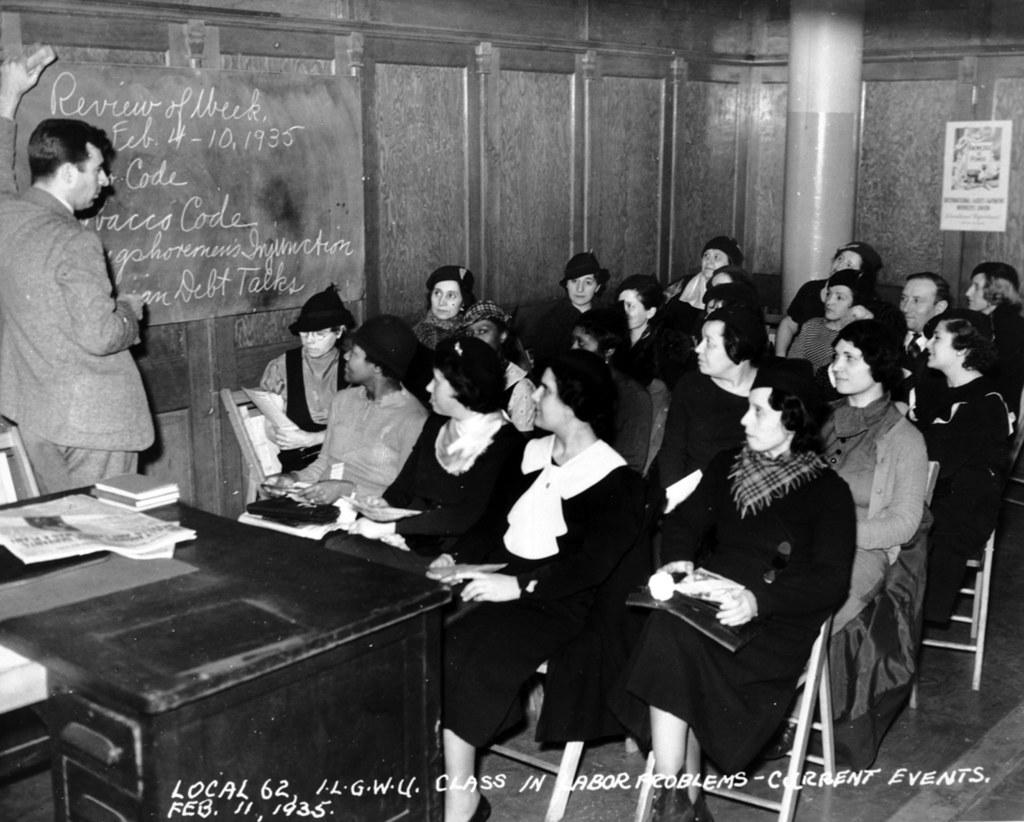How many people are in the image? There is a group of people in the image. What are the people doing in the image? The people are sitting on chairs. Can you describe the person on the left side of the image? There is a person standing on the left side of the image. What can be seen in the background of the image? There is a table, a pillar, a cupboard, and a poster in the background of the image. How many cherries are on the table in the image? There are no cherries mentioned or visible in the image. Can you describe the person jumping over the pillar in the image? There is no person jumping over the pillar in the image; the person on the left side of the image is standing. 